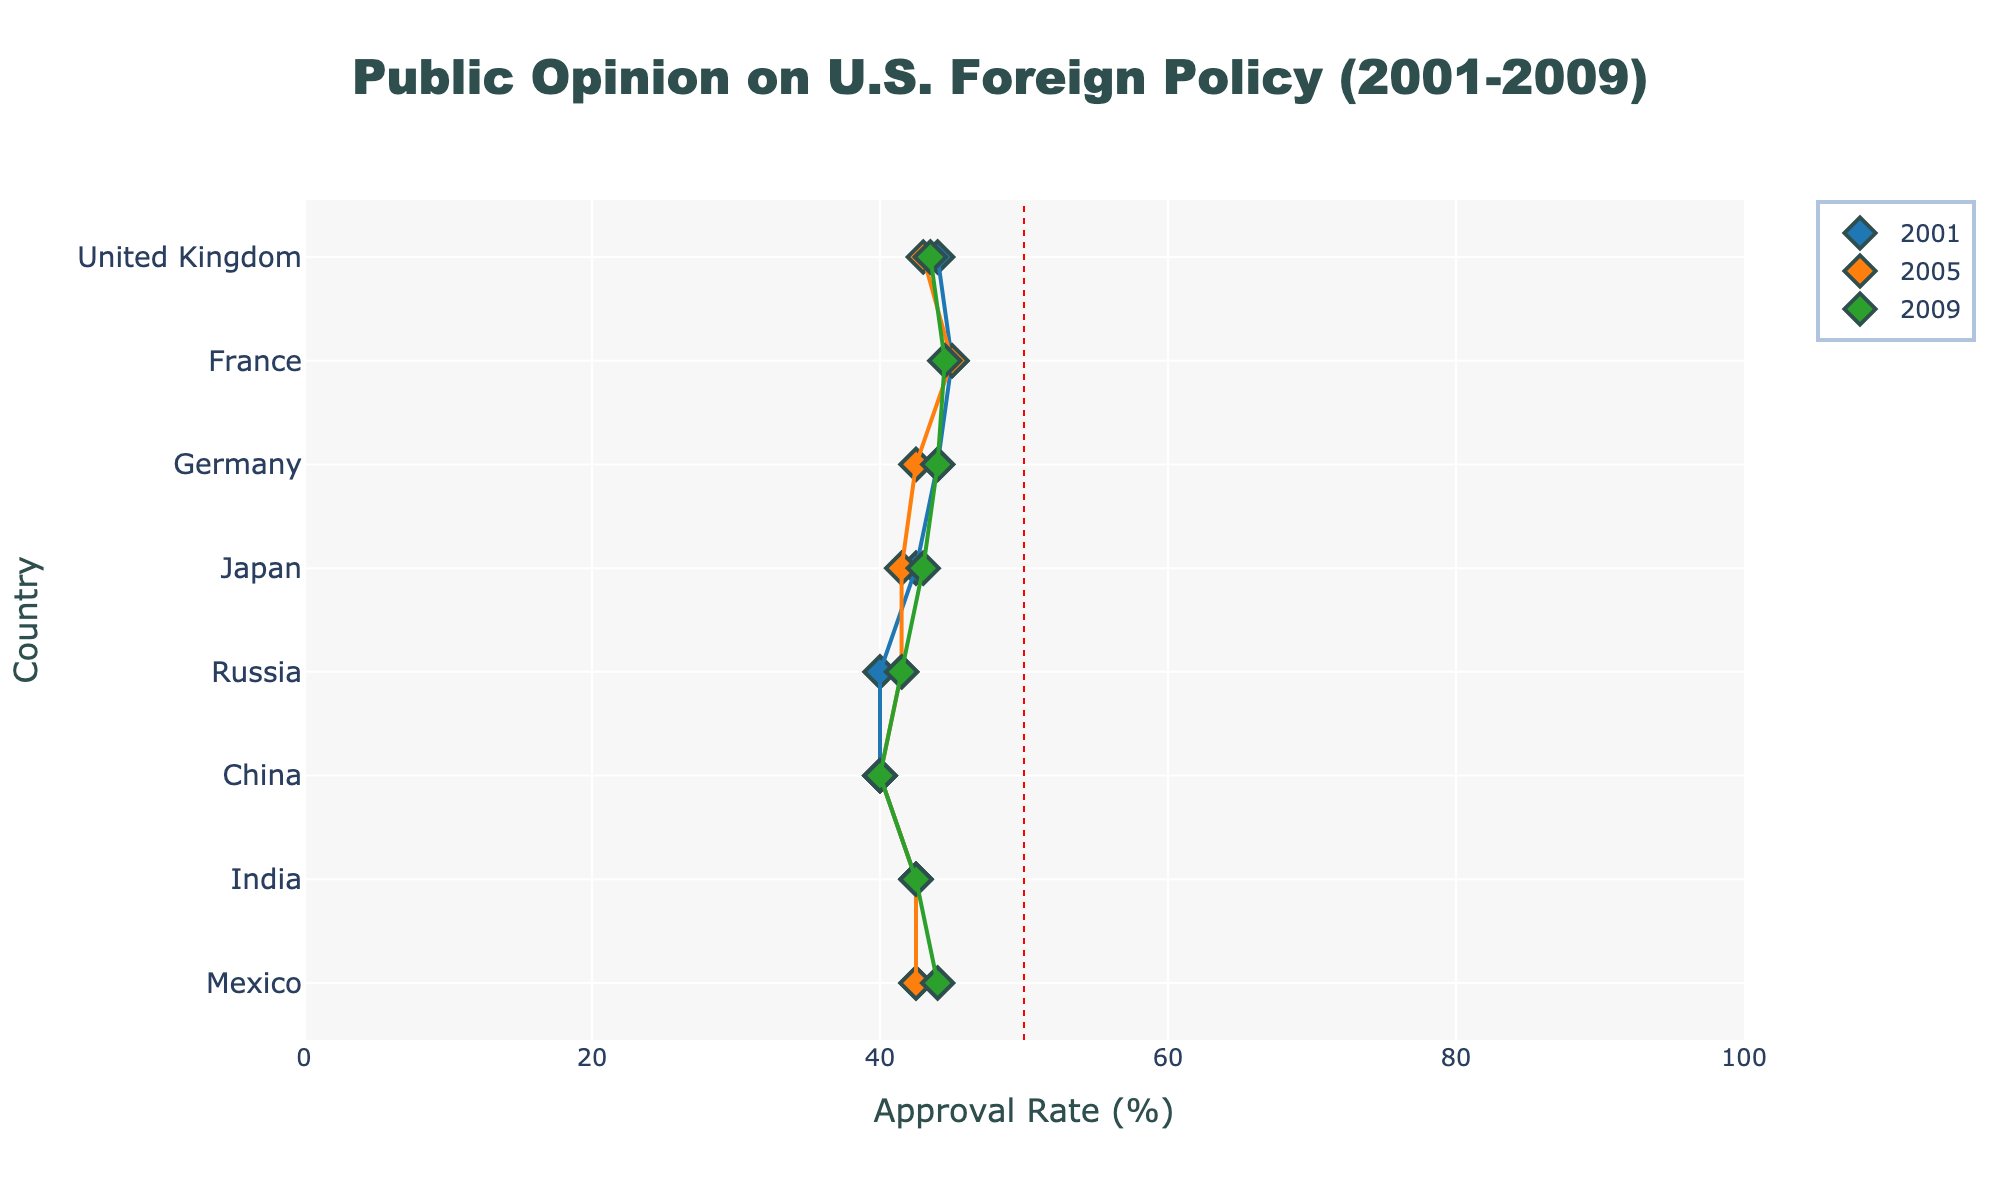What is the title of the figure? The title is displayed at the top of the figure in a larger font size, it reads "Public Opinion on U.S. Foreign Policy (2001-2009)"
Answer: Public Opinion on U.S. Foreign Policy (2001-2009) Which country had the highest approval rate in 2001? By looking at the approval rates marked in the figure for each country in 2001, we see that France has the highest approval rate of 75%.
Answer: France How did the approval rate change in the United Kingdom from 2001 to 2009? In 2001, the approval rate in the United Kingdom was 67%. By 2009, it had decreased to 42%. The reduction can be calculated as 67% - 42% = 25%.
Answer: Decreased by 25% Which year shows the largest disapproval rate in China? By examining the disapproval rates for China across the three years (2001, 2005, 2009), the largest disapproval rate is in 2009, which is 55%.
Answer: 2009 What is the range of opinions (disapproval rate - approval rate) for France in 2009? The disapproval rate for France in 2009 is 55%, and the approval rate is 34%. The range is calculated as 55% - 34% = 21%.
Answer: 21% Which country had the smallest disapproval rate in 2005? By comparing the disapproval rates across all countries in 2005, the United Kingdom had the smallest disapproval rate at 37%.
Answer: United Kingdom How did the disapproval rate in Russia change from 2001 to 2009? In 2001, the disapproval rate in Russia was 50%. By 2009, it had increased to 63%. The increase is 63% - 50% = 13%.
Answer: Increased by 13% Which country's opinion showed the largest drop in the approval rate from 2001 to 2009? Comparing the approval rates in 2001 and 2009, France showed the largest drop from 75% in 2001 to 34% in 2009. The drop is calculated as 75% - 34% = 41%.
Answer: France Which country had the highest midpoint in 2005? The midpoint is the average of the approval and disapproval rates. For each country, calculate the midpoint for 2005, and the highest value belongs to Mexico with (55 + 30)/2 = 42.5.
Answer: Mexico 